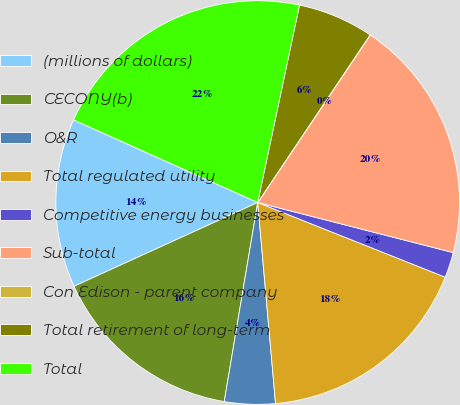Convert chart to OTSL. <chart><loc_0><loc_0><loc_500><loc_500><pie_chart><fcel>(millions of dollars)<fcel>CECONY(b)<fcel>O&R<fcel>Total regulated utility<fcel>Competitive energy businesses<fcel>Sub-total<fcel>Con Edison - parent company<fcel>Total retirement of long-term<fcel>Total<nl><fcel>13.52%<fcel>15.54%<fcel>4.06%<fcel>17.56%<fcel>2.04%<fcel>19.58%<fcel>0.01%<fcel>6.08%<fcel>21.61%<nl></chart> 